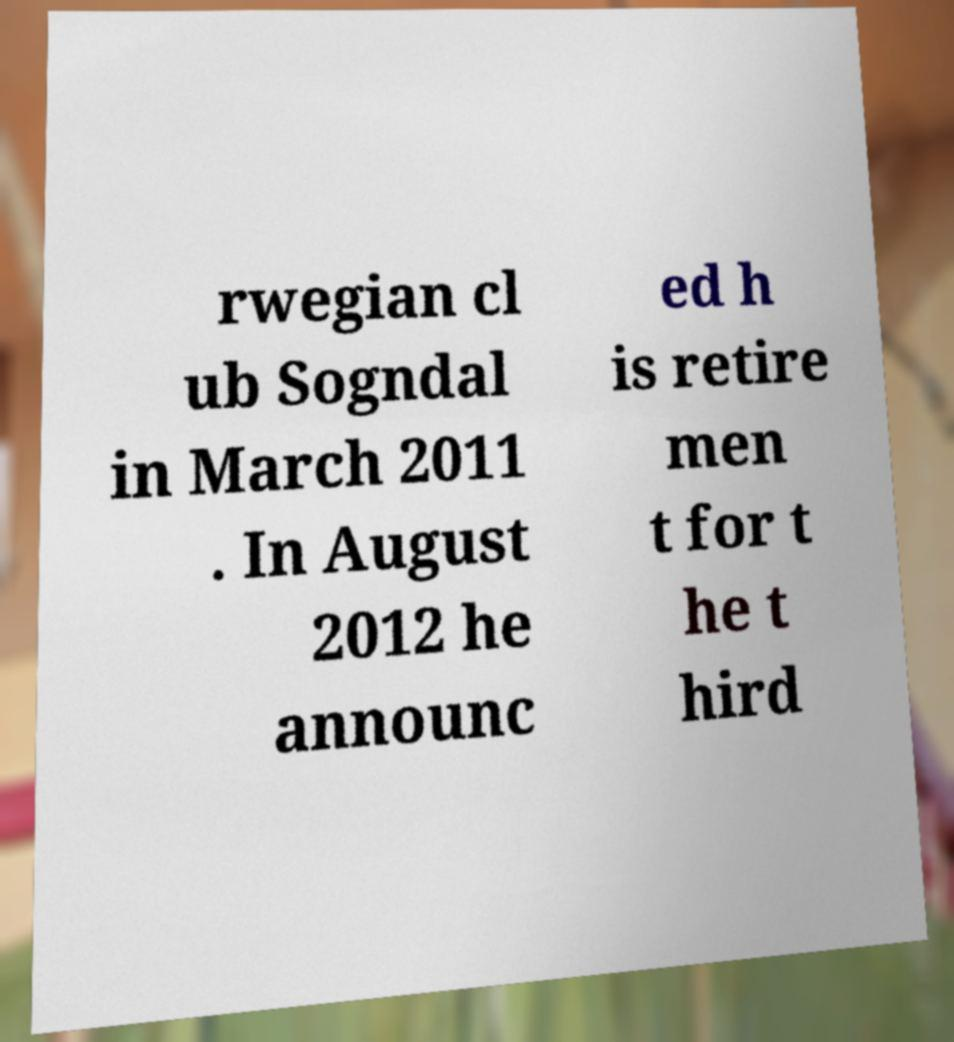I need the written content from this picture converted into text. Can you do that? rwegian cl ub Sogndal in March 2011 . In August 2012 he announc ed h is retire men t for t he t hird 